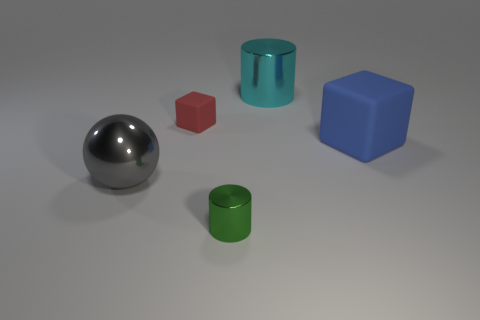There is a big metallic thing to the right of the metallic sphere; is it the same color as the big cube?
Give a very brief answer. No. How many other things are there of the same shape as the gray object?
Ensure brevity in your answer.  0. How many other things are there of the same material as the gray ball?
Ensure brevity in your answer.  2. There is a cylinder in front of the rubber object that is to the left of the large blue rubber cube that is in front of the big cylinder; what is it made of?
Give a very brief answer. Metal. Do the large gray thing and the red block have the same material?
Offer a very short reply. No. What number of blocks are either blue metallic objects or green objects?
Your answer should be compact. 0. The large object left of the small cube is what color?
Offer a terse response. Gray. How many matte things are either big gray balls or blue objects?
Ensure brevity in your answer.  1. There is a cylinder in front of the object that is to the left of the tiny red rubber thing; what is it made of?
Offer a very short reply. Metal. The large rubber cube has what color?
Make the answer very short. Blue. 